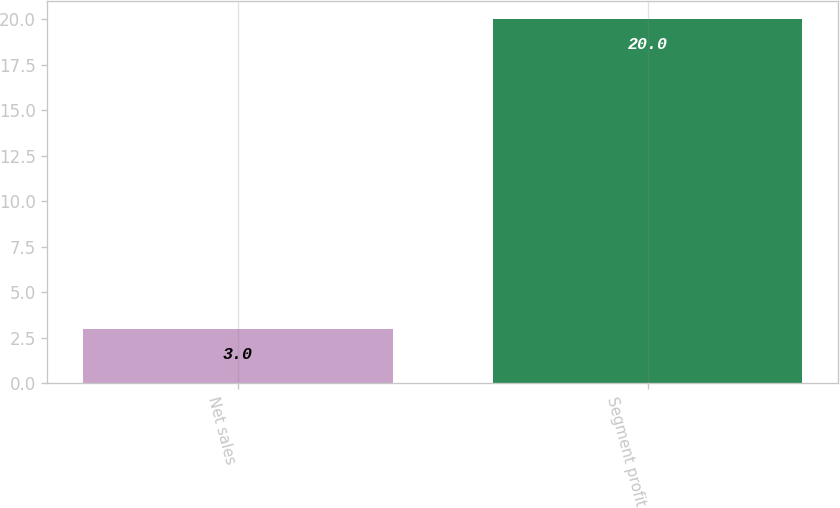<chart> <loc_0><loc_0><loc_500><loc_500><bar_chart><fcel>Net sales<fcel>Segment profit<nl><fcel>3<fcel>20<nl></chart> 